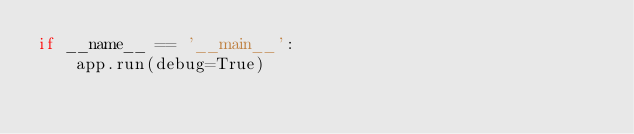Convert code to text. <code><loc_0><loc_0><loc_500><loc_500><_Python_>if __name__ == '__main__':
    app.run(debug=True)</code> 